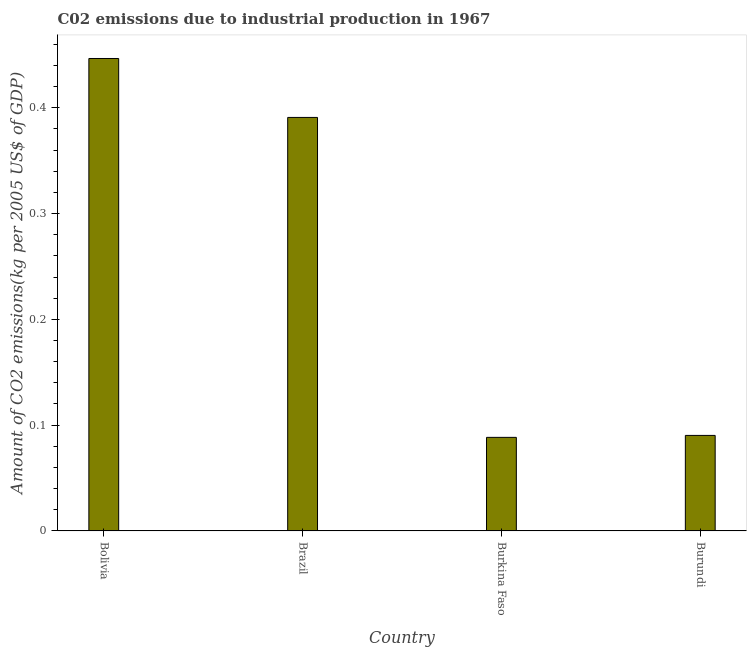Does the graph contain any zero values?
Provide a short and direct response. No. What is the title of the graph?
Provide a short and direct response. C02 emissions due to industrial production in 1967. What is the label or title of the X-axis?
Provide a short and direct response. Country. What is the label or title of the Y-axis?
Make the answer very short. Amount of CO2 emissions(kg per 2005 US$ of GDP). What is the amount of co2 emissions in Brazil?
Keep it short and to the point. 0.39. Across all countries, what is the maximum amount of co2 emissions?
Offer a terse response. 0.45. Across all countries, what is the minimum amount of co2 emissions?
Your answer should be very brief. 0.09. In which country was the amount of co2 emissions maximum?
Your response must be concise. Bolivia. In which country was the amount of co2 emissions minimum?
Your response must be concise. Burkina Faso. What is the sum of the amount of co2 emissions?
Your answer should be very brief. 1.02. What is the difference between the amount of co2 emissions in Bolivia and Brazil?
Your answer should be very brief. 0.06. What is the average amount of co2 emissions per country?
Provide a succinct answer. 0.25. What is the median amount of co2 emissions?
Your response must be concise. 0.24. In how many countries, is the amount of co2 emissions greater than 0.14 kg per 2005 US$ of GDP?
Offer a terse response. 2. What is the ratio of the amount of co2 emissions in Bolivia to that in Burkina Faso?
Keep it short and to the point. 5.05. Is the difference between the amount of co2 emissions in Bolivia and Brazil greater than the difference between any two countries?
Provide a succinct answer. No. What is the difference between the highest and the second highest amount of co2 emissions?
Keep it short and to the point. 0.06. What is the difference between the highest and the lowest amount of co2 emissions?
Make the answer very short. 0.36. How many countries are there in the graph?
Provide a short and direct response. 4. What is the difference between two consecutive major ticks on the Y-axis?
Your answer should be compact. 0.1. What is the Amount of CO2 emissions(kg per 2005 US$ of GDP) of Bolivia?
Give a very brief answer. 0.45. What is the Amount of CO2 emissions(kg per 2005 US$ of GDP) in Brazil?
Offer a terse response. 0.39. What is the Amount of CO2 emissions(kg per 2005 US$ of GDP) in Burkina Faso?
Provide a short and direct response. 0.09. What is the Amount of CO2 emissions(kg per 2005 US$ of GDP) in Burundi?
Keep it short and to the point. 0.09. What is the difference between the Amount of CO2 emissions(kg per 2005 US$ of GDP) in Bolivia and Brazil?
Offer a very short reply. 0.06. What is the difference between the Amount of CO2 emissions(kg per 2005 US$ of GDP) in Bolivia and Burkina Faso?
Your answer should be compact. 0.36. What is the difference between the Amount of CO2 emissions(kg per 2005 US$ of GDP) in Bolivia and Burundi?
Offer a very short reply. 0.36. What is the difference between the Amount of CO2 emissions(kg per 2005 US$ of GDP) in Brazil and Burkina Faso?
Offer a very short reply. 0.3. What is the difference between the Amount of CO2 emissions(kg per 2005 US$ of GDP) in Brazil and Burundi?
Offer a very short reply. 0.3. What is the difference between the Amount of CO2 emissions(kg per 2005 US$ of GDP) in Burkina Faso and Burundi?
Offer a very short reply. -0. What is the ratio of the Amount of CO2 emissions(kg per 2005 US$ of GDP) in Bolivia to that in Brazil?
Your answer should be very brief. 1.14. What is the ratio of the Amount of CO2 emissions(kg per 2005 US$ of GDP) in Bolivia to that in Burkina Faso?
Keep it short and to the point. 5.05. What is the ratio of the Amount of CO2 emissions(kg per 2005 US$ of GDP) in Bolivia to that in Burundi?
Your answer should be compact. 4.95. What is the ratio of the Amount of CO2 emissions(kg per 2005 US$ of GDP) in Brazil to that in Burkina Faso?
Provide a succinct answer. 4.42. What is the ratio of the Amount of CO2 emissions(kg per 2005 US$ of GDP) in Brazil to that in Burundi?
Ensure brevity in your answer.  4.33. 